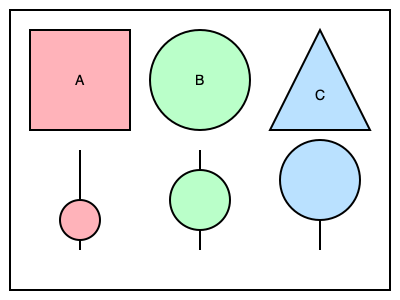The diagram shows three teaching methodologies (A, B, and C) and their corresponding student engagement levels. Which methodology appears to have the highest level of student engagement, and how might this inform your teaching approach in a community college setting? 1. Analyze the diagram:
   - Method A (square): Traditional lecture
   - Method B (circle): Group discussion
   - Method C (triangle): Hands-on project

2. Observe the engagement levels:
   - A has the smallest circle at the bottom
   - B has a medium-sized circle
   - C has the largest circle

3. Interpret the results:
   - Larger circles indicate higher engagement levels
   - Method C (hands-on project) shows the highest engagement

4. Apply to community college setting:
   - Community college students often benefit from practical, hands-on learning
   - Method C aligns well with vocational and applied learning common in community colleges
   - Incorporating hands-on projects can increase student engagement and retention

5. Consider implementation:
   - Integrate more hands-on projects into course curriculum
   - Balance with other methods for diverse learning styles
   - Ensure projects are relevant to course objectives and future career applications

6. Reflect on limitations:
   - Different subjects may require varied approaches
   - Individual student needs should be considered
   - A mix of methodologies may be most effective overall
Answer: Method C (hands-on project); implement more practical, project-based learning activities. 